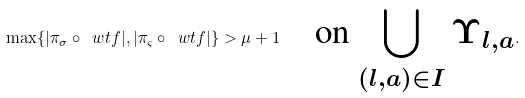<formula> <loc_0><loc_0><loc_500><loc_500>\max \{ | \pi _ { \sigma } \circ \ w t f | , | \pi _ { \varsigma } \circ \ w t f | \} > \mu + 1 \quad \text {on $\bigcup_{(l,a)\in I}\Upsilon_{l,a}$} .</formula> 